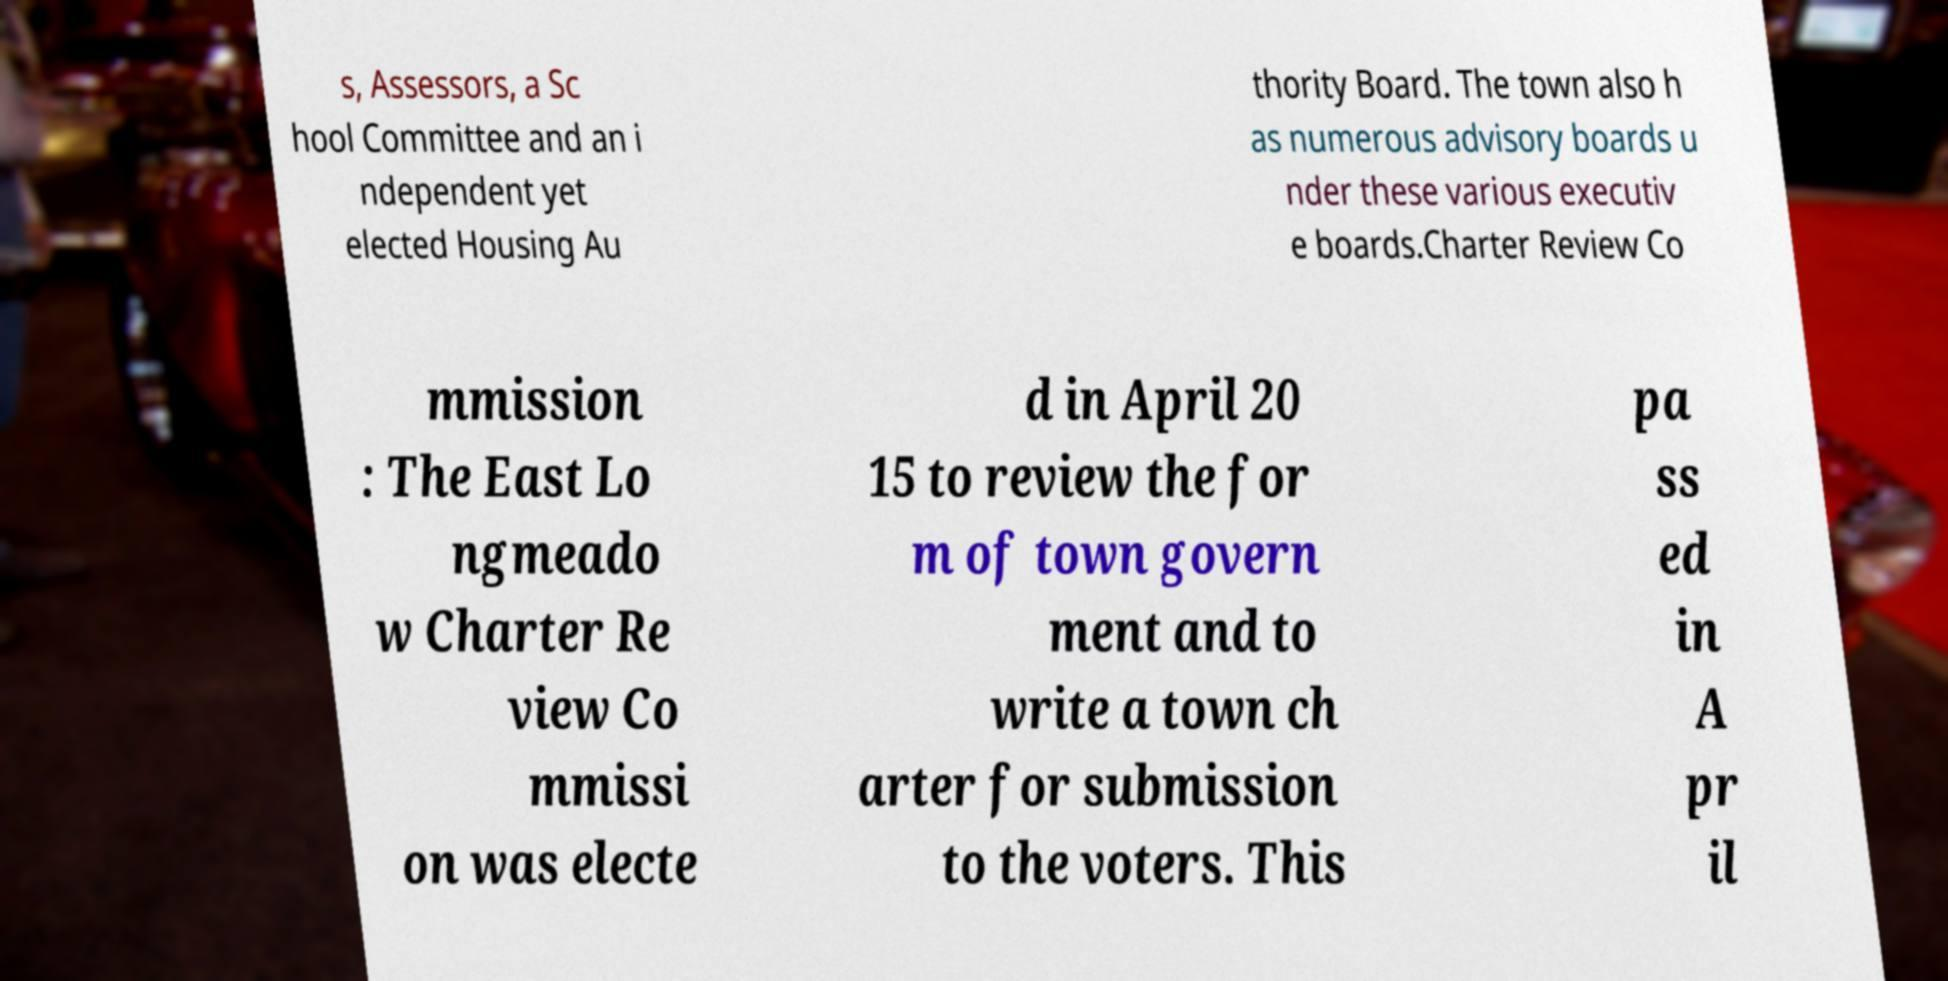Please identify and transcribe the text found in this image. s, Assessors, a Sc hool Committee and an i ndependent yet elected Housing Au thority Board. The town also h as numerous advisory boards u nder these various executiv e boards.Charter Review Co mmission : The East Lo ngmeado w Charter Re view Co mmissi on was electe d in April 20 15 to review the for m of town govern ment and to write a town ch arter for submission to the voters. This pa ss ed in A pr il 